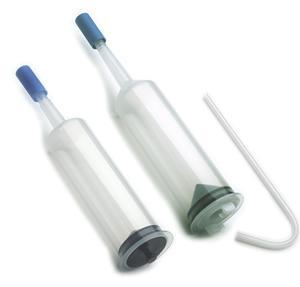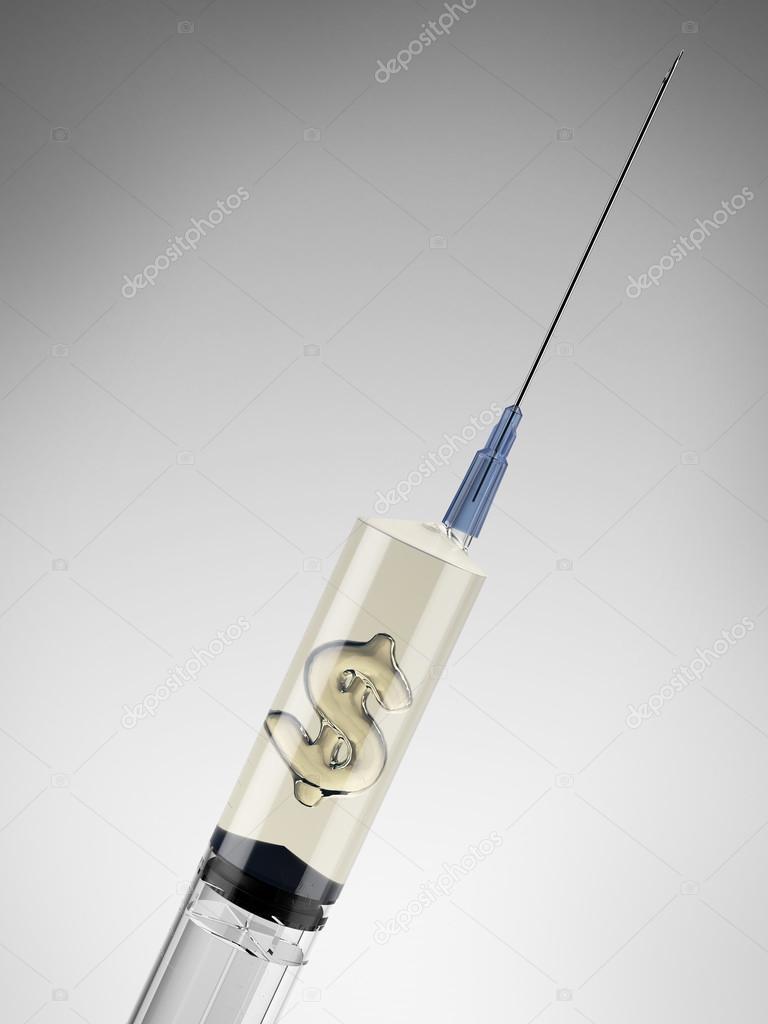The first image is the image on the left, the second image is the image on the right. Given the left and right images, does the statement "The right image contains paper money and a syringe." hold true? Answer yes or no. No. The first image is the image on the left, the second image is the image on the right. Assess this claim about the two images: "American money is visible in one of the images.". Correct or not? Answer yes or no. No. 